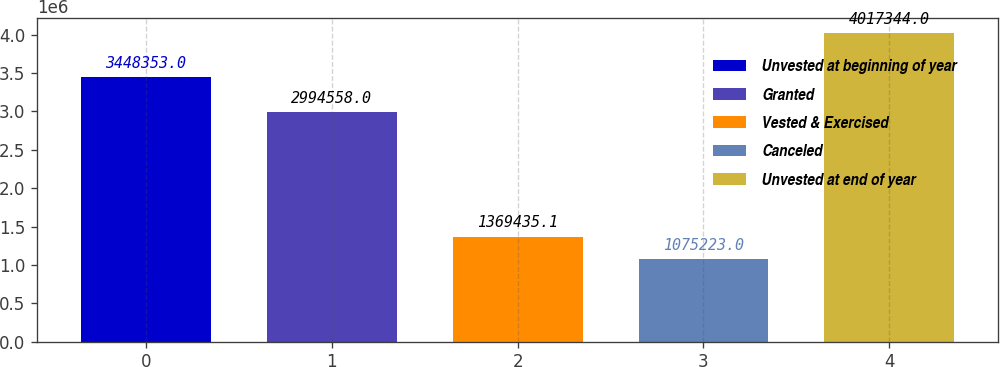<chart> <loc_0><loc_0><loc_500><loc_500><bar_chart><fcel>Unvested at beginning of year<fcel>Granted<fcel>Vested & Exercised<fcel>Canceled<fcel>Unvested at end of year<nl><fcel>3.44835e+06<fcel>2.99456e+06<fcel>1.36944e+06<fcel>1.07522e+06<fcel>4.01734e+06<nl></chart> 